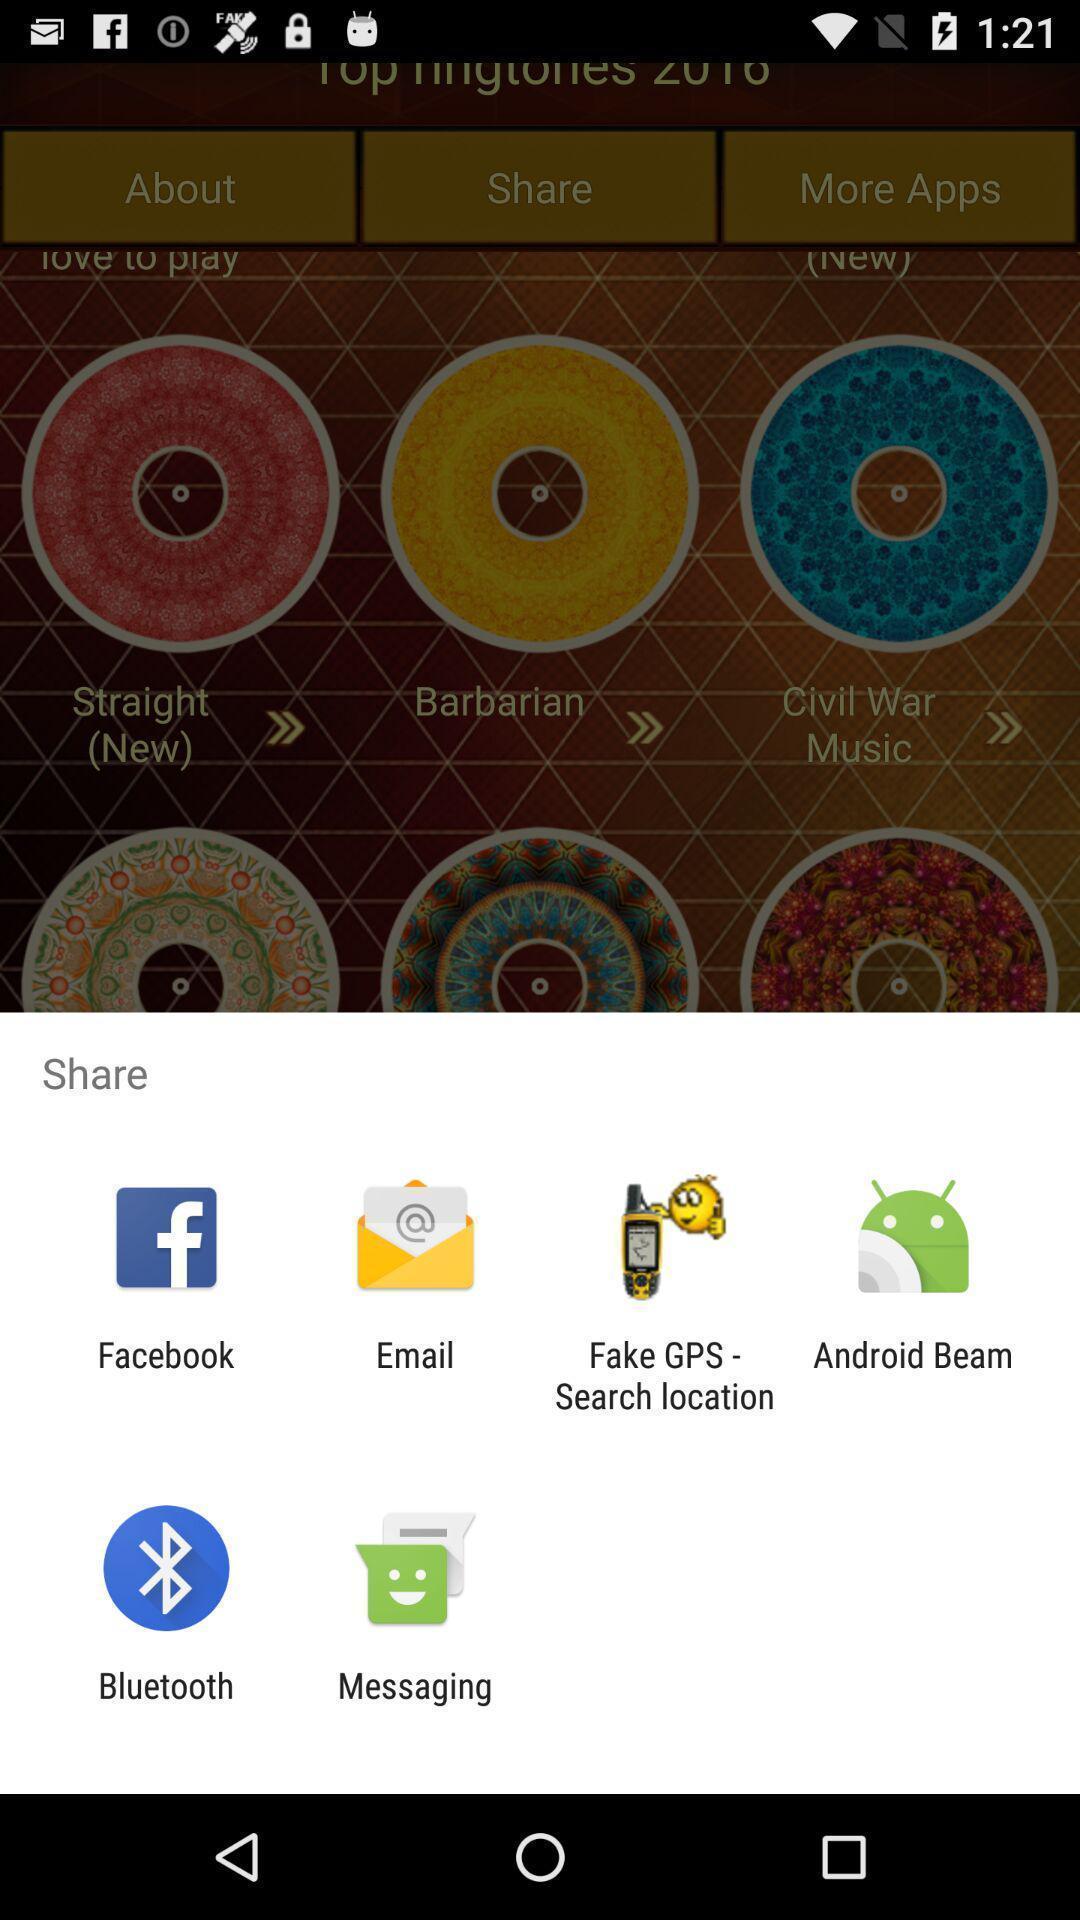Provide a description of this screenshot. Pop-up shows share option with multiple applications. 